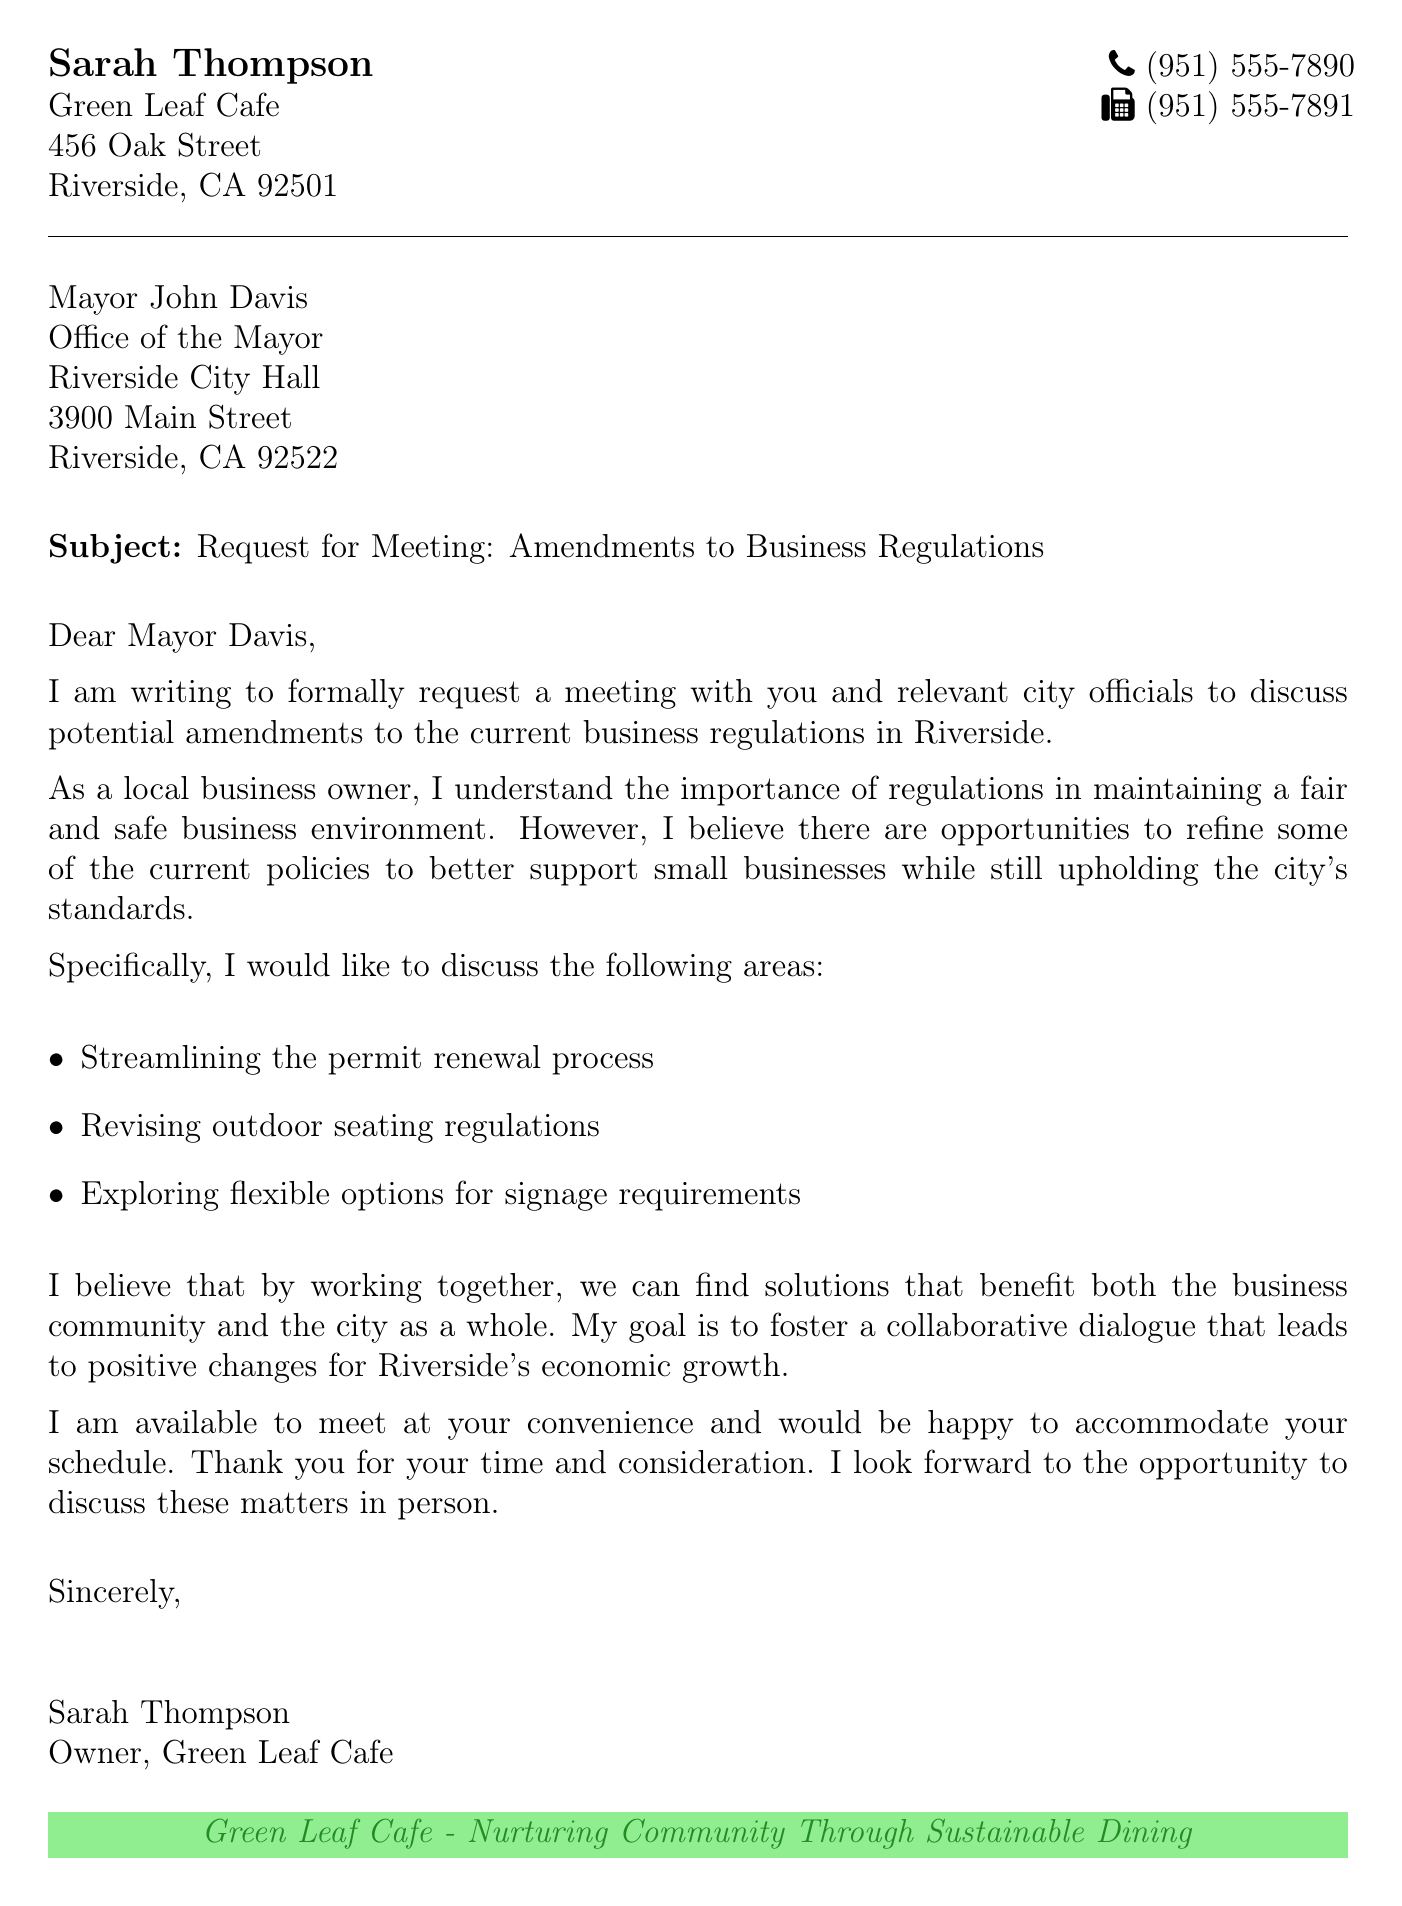What is the name of the sender? The sender is identified at the top of the document as Sarah Thompson.
Answer: Sarah Thompson What is the fax number provided? The fax number can be found in the contact information section of the document.
Answer: (951) 555-7891 Who is the recipient of the fax? The document states the recipient as Mayor John Davis.
Answer: Mayor John Davis What are the three specific areas the sender wants to discuss? The areas are listed under the itemized section, summarizing the main points of discussion.
Answer: Permit renewal process, outdoor seating regulations, signage requirements What is the purpose of this document? The document is a formal request indicating the sender's intention to meet and discuss business regulation amendments.
Answer: Request for a meeting What is the subject of the fax? The subject line clearly states the topic of communication in a formal manner.
Answer: Request for Meeting: Amendments to Business Regulations What is the address of the Green Leaf Cafe? The address is included in the sender's contact information section at the top of the document.
Answer: 456 Oak Street, Riverside, CA 92501 What is the closing sentiment expressed in the letter? The closing line reflects the sender's eagerness for collaboration and future discussions.
Answer: Look forward to the opportunity to discuss these matters What design element is emphasized at the end of the document? The elements are visually designed to represent the cafe's ethos as seen in the concluding section.
Answer: Green Leaf Cafe - Nurturing Community Through Sustainable Dining 